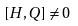<formula> <loc_0><loc_0><loc_500><loc_500>[ H , Q ] \ne 0</formula> 